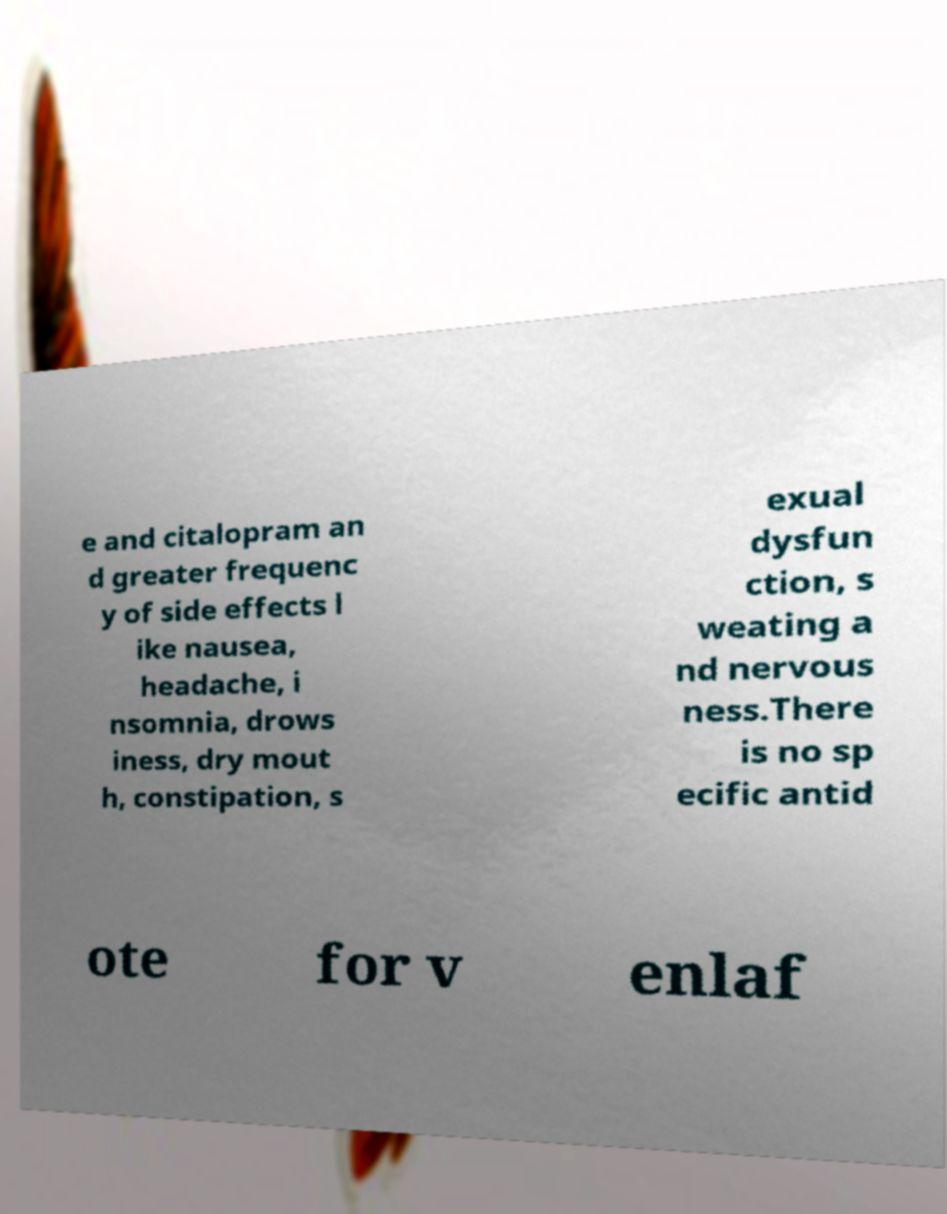I need the written content from this picture converted into text. Can you do that? e and citalopram an d greater frequenc y of side effects l ike nausea, headache, i nsomnia, drows iness, dry mout h, constipation, s exual dysfun ction, s weating a nd nervous ness.There is no sp ecific antid ote for v enlaf 